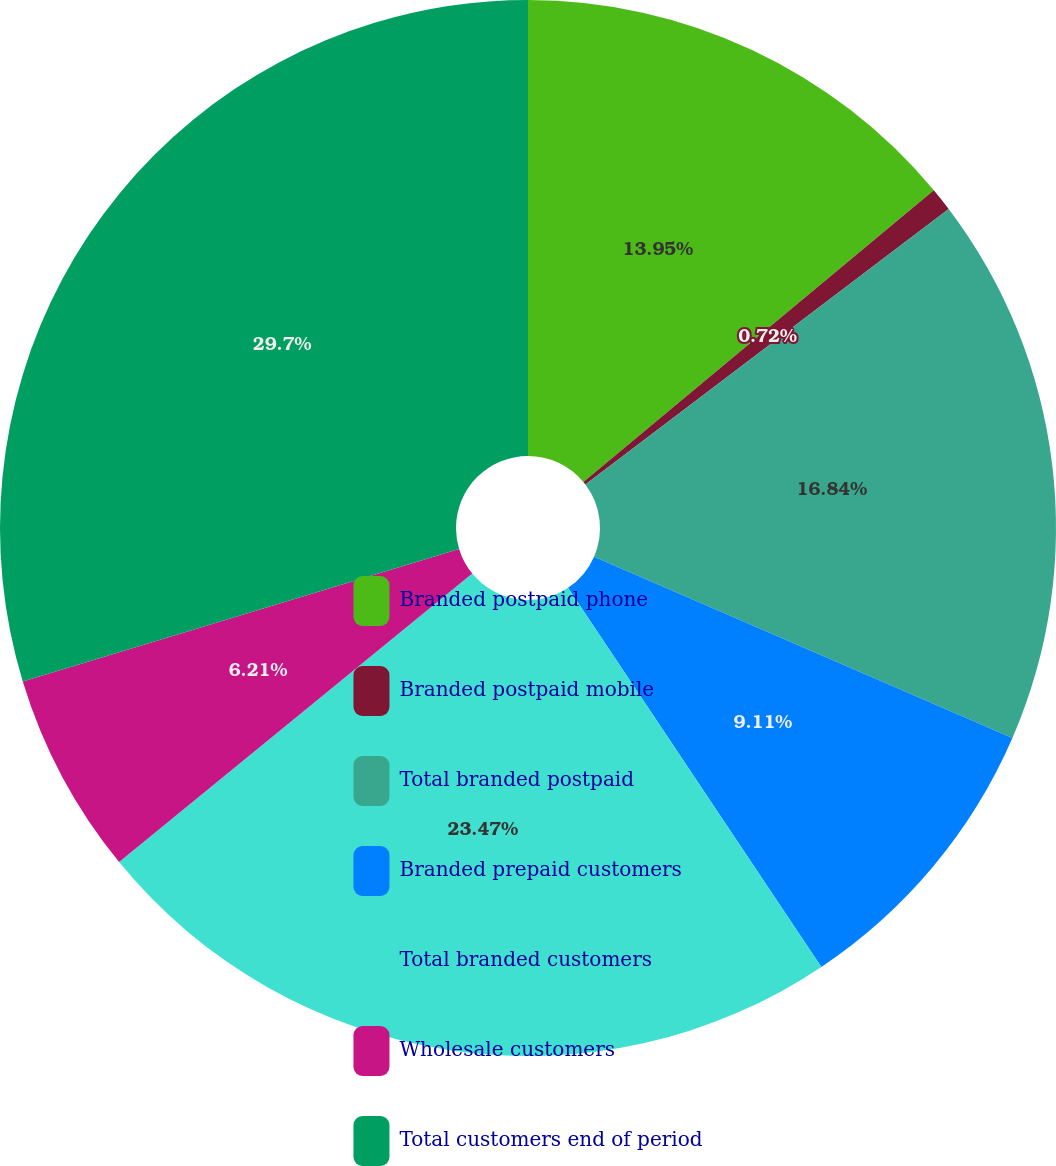<chart> <loc_0><loc_0><loc_500><loc_500><pie_chart><fcel>Branded postpaid phone<fcel>Branded postpaid mobile<fcel>Total branded postpaid<fcel>Branded prepaid customers<fcel>Total branded customers<fcel>Wholesale customers<fcel>Total customers end of period<nl><fcel>13.95%<fcel>0.72%<fcel>16.84%<fcel>9.11%<fcel>23.47%<fcel>6.21%<fcel>29.69%<nl></chart> 